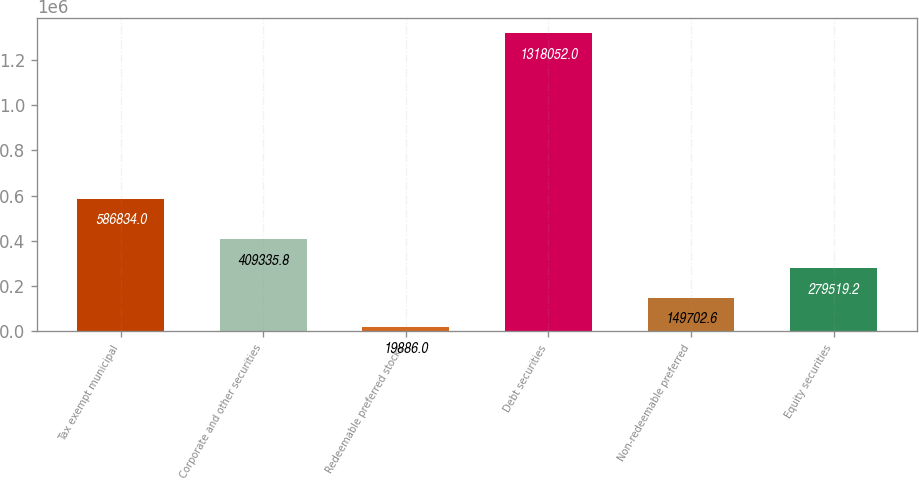Convert chart to OTSL. <chart><loc_0><loc_0><loc_500><loc_500><bar_chart><fcel>Tax exempt municipal<fcel>Corporate and other securities<fcel>Redeemable preferred stocks<fcel>Debt securities<fcel>Non-redeemable preferred<fcel>Equity securities<nl><fcel>586834<fcel>409336<fcel>19886<fcel>1.31805e+06<fcel>149703<fcel>279519<nl></chart> 